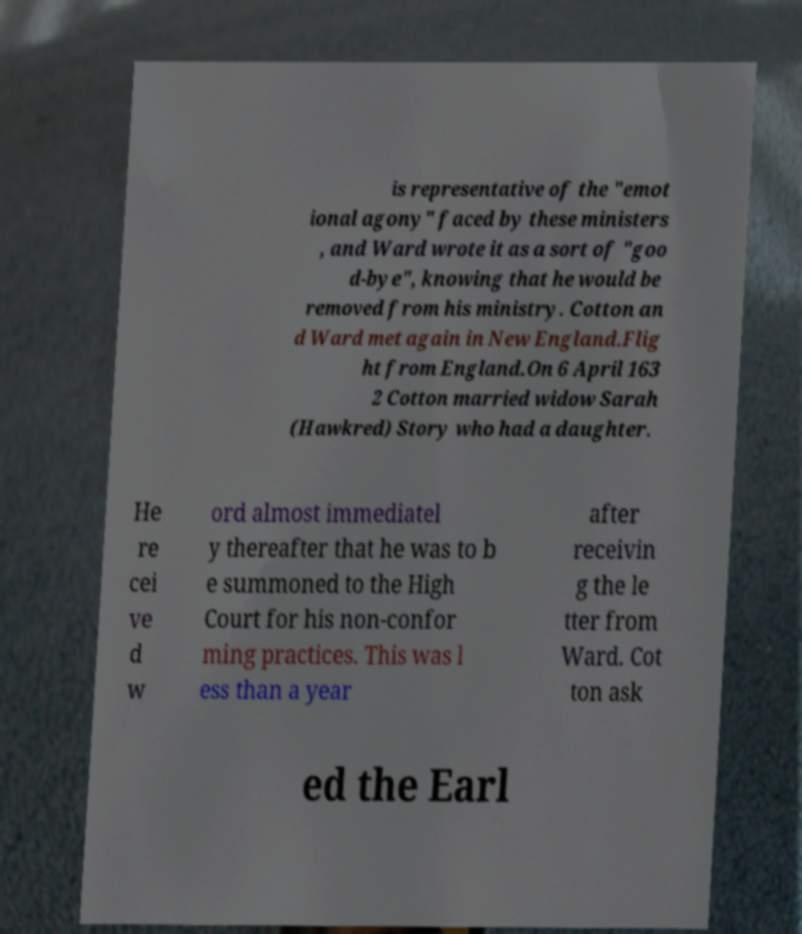There's text embedded in this image that I need extracted. Can you transcribe it verbatim? is representative of the "emot ional agony" faced by these ministers , and Ward wrote it as a sort of "goo d-bye", knowing that he would be removed from his ministry. Cotton an d Ward met again in New England.Flig ht from England.On 6 April 163 2 Cotton married widow Sarah (Hawkred) Story who had a daughter. He re cei ve d w ord almost immediatel y thereafter that he was to b e summoned to the High Court for his non-confor ming practices. This was l ess than a year after receivin g the le tter from Ward. Cot ton ask ed the Earl 